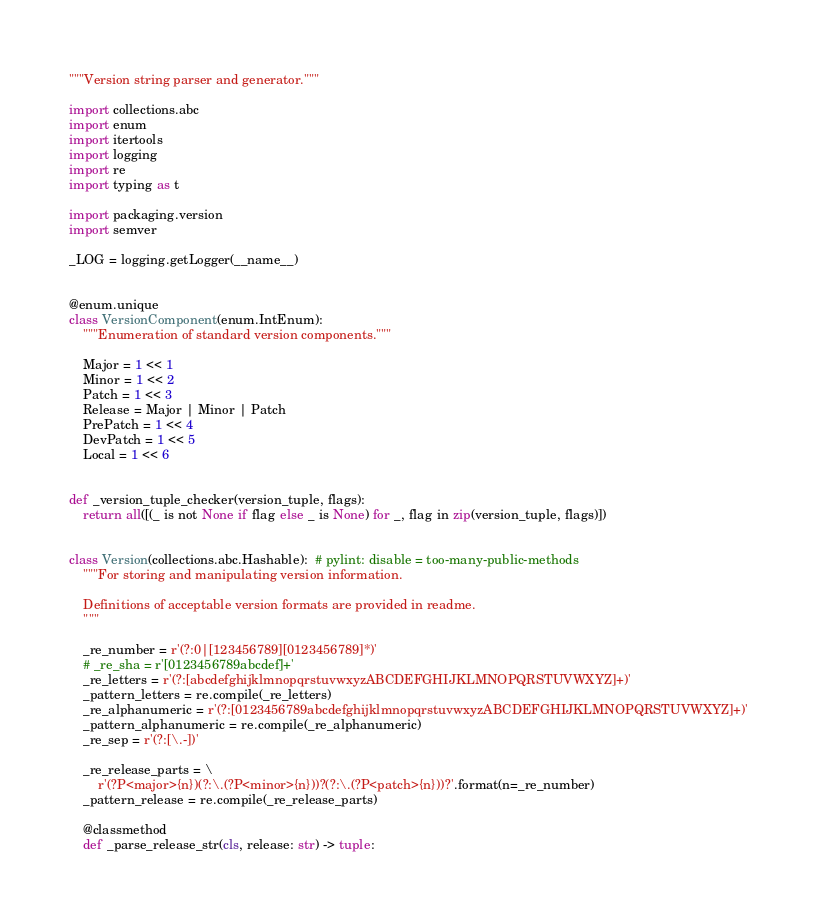Convert code to text. <code><loc_0><loc_0><loc_500><loc_500><_Python_>"""Version string parser and generator."""

import collections.abc
import enum
import itertools
import logging
import re
import typing as t

import packaging.version
import semver

_LOG = logging.getLogger(__name__)


@enum.unique
class VersionComponent(enum.IntEnum):
    """Enumeration of standard version components."""

    Major = 1 << 1
    Minor = 1 << 2
    Patch = 1 << 3
    Release = Major | Minor | Patch
    PrePatch = 1 << 4
    DevPatch = 1 << 5
    Local = 1 << 6


def _version_tuple_checker(version_tuple, flags):
    return all([(_ is not None if flag else _ is None) for _, flag in zip(version_tuple, flags)])


class Version(collections.abc.Hashable):  # pylint: disable = too-many-public-methods
    """For storing and manipulating version information.

    Definitions of acceptable version formats are provided in readme.
    """

    _re_number = r'(?:0|[123456789][0123456789]*)'
    # _re_sha = r'[0123456789abcdef]+'
    _re_letters = r'(?:[abcdefghijklmnopqrstuvwxyzABCDEFGHIJKLMNOPQRSTUVWXYZ]+)'
    _pattern_letters = re.compile(_re_letters)
    _re_alphanumeric = r'(?:[0123456789abcdefghijklmnopqrstuvwxyzABCDEFGHIJKLMNOPQRSTUVWXYZ]+)'
    _pattern_alphanumeric = re.compile(_re_alphanumeric)
    _re_sep = r'(?:[\.-])'

    _re_release_parts = \
        r'(?P<major>{n})(?:\.(?P<minor>{n}))?(?:\.(?P<patch>{n}))?'.format(n=_re_number)
    _pattern_release = re.compile(_re_release_parts)

    @classmethod
    def _parse_release_str(cls, release: str) -> tuple:</code> 